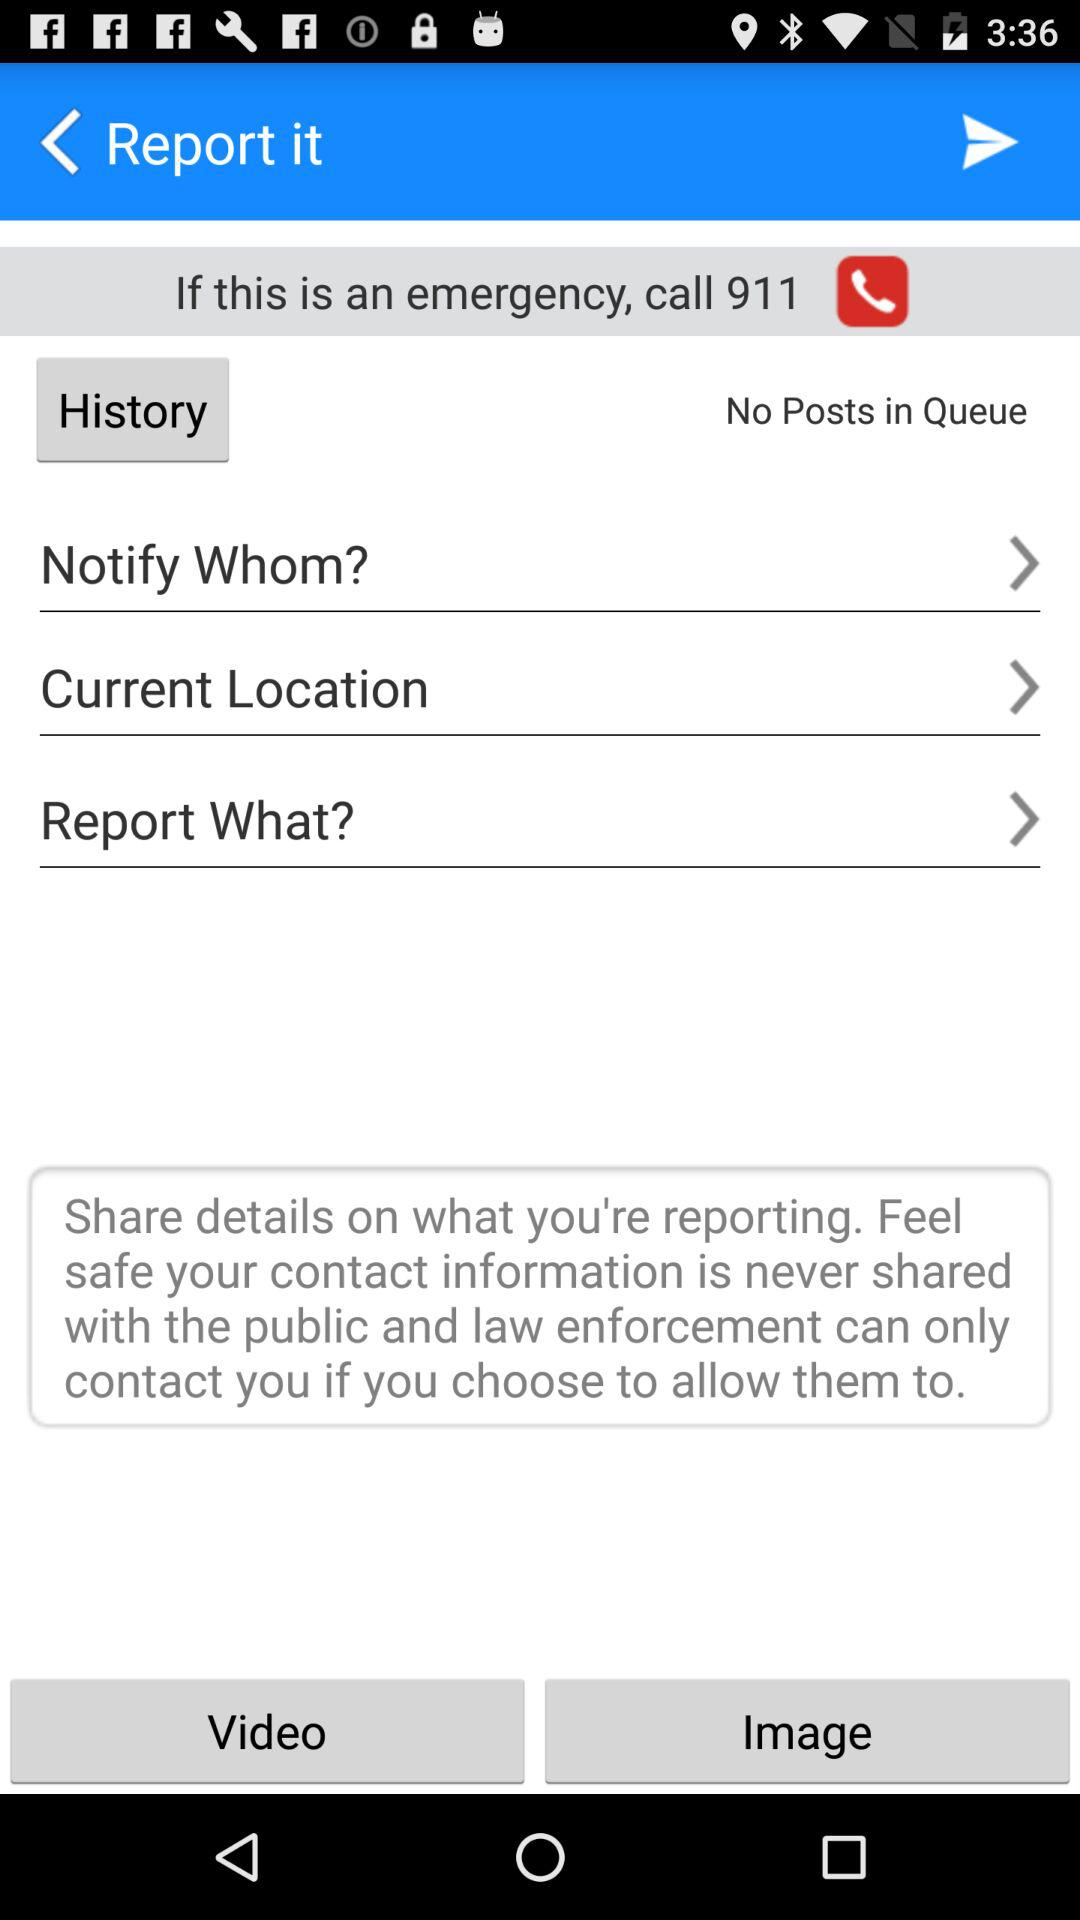How many posts are in the queue? There are no posts in the queue. 